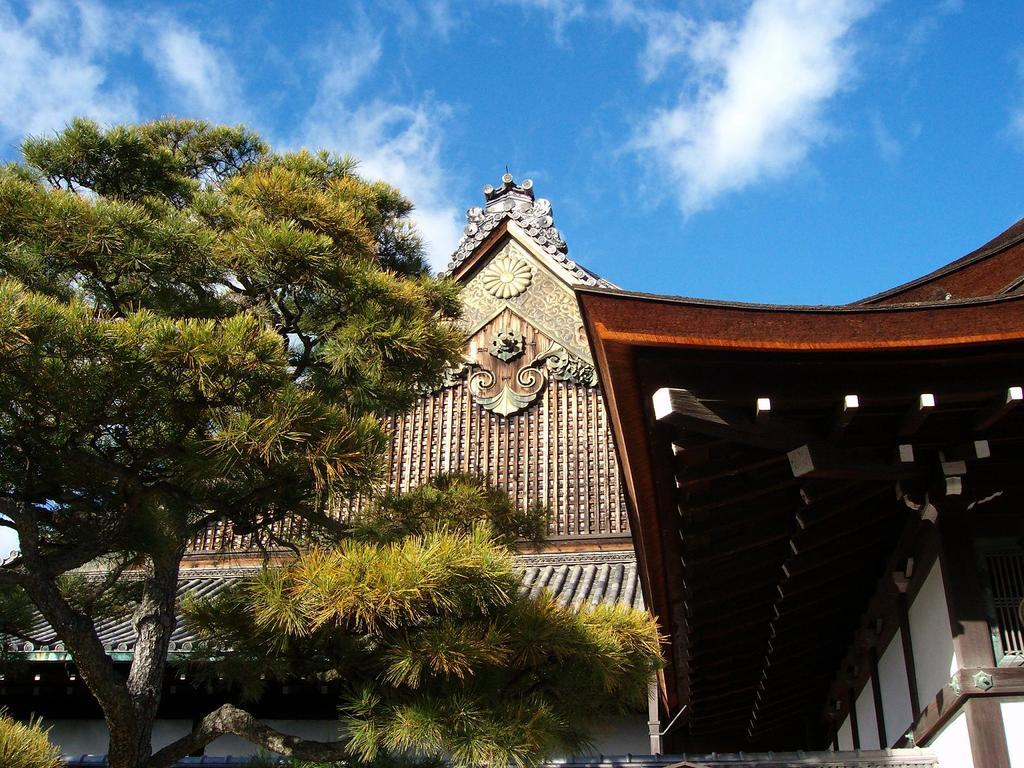What type of natural elements can be seen in the image? There are trees in the image. What type of man-made structures are visible in the image? There are buildings in the image. What is visible in the background of the image? The sky is visible in the background of the image. What can be observed in the sky? Clouds are present in the sky. Can you see a hose connecting the trees and buildings in the image? There is no hose connecting the trees and buildings in the image. Is there a turkey visible among the trees in the image? There is no turkey present in the image. 